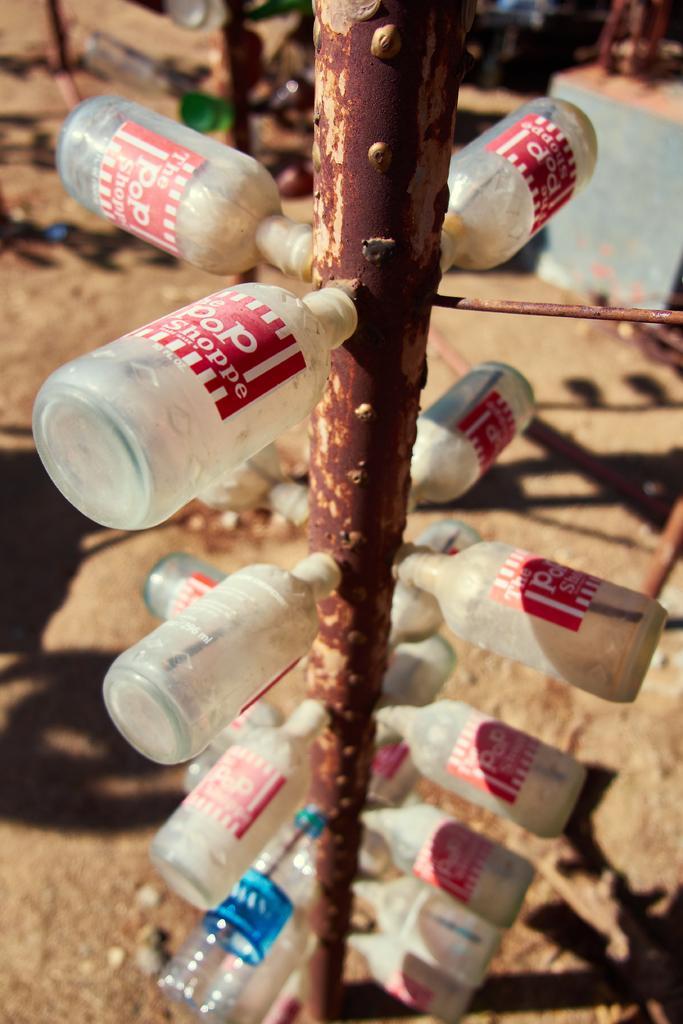Could you give a brief overview of what you see in this image? These bottles are attached to this pole. 